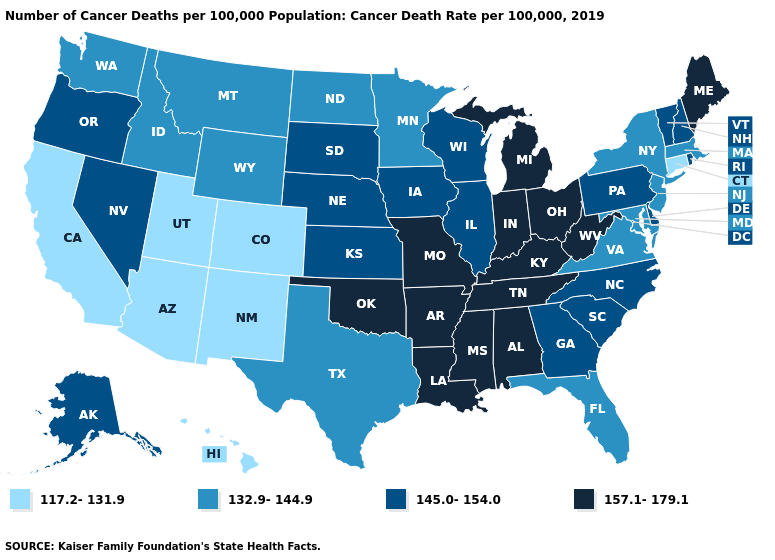What is the lowest value in the USA?
Quick response, please. 117.2-131.9. Name the states that have a value in the range 117.2-131.9?
Write a very short answer. Arizona, California, Colorado, Connecticut, Hawaii, New Mexico, Utah. Does Alabama have the highest value in the USA?
Concise answer only. Yes. What is the highest value in the MidWest ?
Quick response, please. 157.1-179.1. Does Arizona have the lowest value in the USA?
Give a very brief answer. Yes. What is the value of South Carolina?
Keep it brief. 145.0-154.0. Does North Dakota have the highest value in the USA?
Concise answer only. No. What is the value of Texas?
Be succinct. 132.9-144.9. What is the highest value in states that border New York?
Quick response, please. 145.0-154.0. Does Connecticut have the lowest value in the Northeast?
Give a very brief answer. Yes. What is the value of Massachusetts?
Answer briefly. 132.9-144.9. Which states hav the highest value in the MidWest?
Be succinct. Indiana, Michigan, Missouri, Ohio. Does South Dakota have the same value as Kansas?
Be succinct. Yes. What is the highest value in the USA?
Keep it brief. 157.1-179.1. Does Idaho have a higher value than Utah?
Write a very short answer. Yes. 